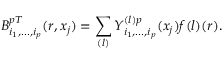<formula> <loc_0><loc_0><loc_500><loc_500>B _ { i _ { 1 } , \dots , i _ { p } } ^ { p T } ( r , x _ { j } ) = \sum _ { ( l ) } Y _ { i _ { 1 } , \dots , i _ { p } } ^ { ( l ) p } ( x _ { j } ) f { ( l ) } ( r ) .</formula> 